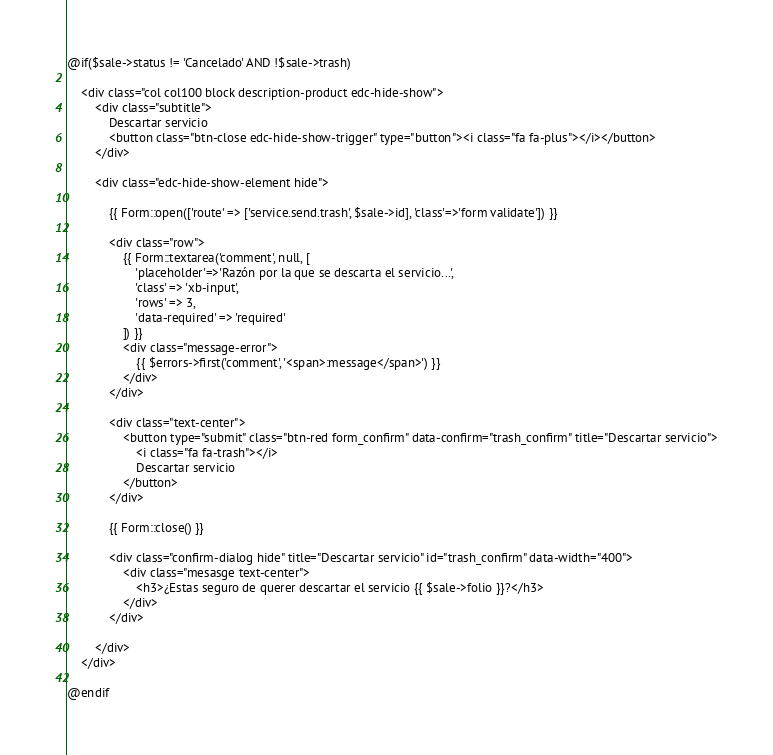Convert code to text. <code><loc_0><loc_0><loc_500><loc_500><_PHP_>@if($sale->status != 'Cancelado' AND !$sale->trash)

    <div class="col col100 block description-product edc-hide-show">
        <div class="subtitle">
            Descartar servicio
            <button class="btn-close edc-hide-show-trigger" type="button"><i class="fa fa-plus"></i></button>
        </div>

        <div class="edc-hide-show-element hide">

            {{ Form::open(['route' => ['service.send.trash', $sale->id], 'class'=>'form validate']) }}

            <div class="row">
                {{ Form::textarea('comment', null, [
                    'placeholder'=>'Razón por la que se descarta el servicio...',
                    'class' => 'xb-input',
                    'rows' => 3,
                    'data-required' => 'required'
                ]) }}
                <div class="message-error">
                    {{ $errors->first('comment', '<span>:message</span>') }}
                </div>
            </div>

            <div class="text-center">
                <button type="submit" class="btn-red form_confirm" data-confirm="trash_confirm" title="Descartar servicio">
                    <i class="fa fa-trash"></i>
                    Descartar servicio
                </button>
            </div>

            {{ Form::close() }}

            <div class="confirm-dialog hide" title="Descartar servicio" id="trash_confirm" data-width="400">
                <div class="mesasge text-center">
                    <h3>¿Estas seguro de querer descartar el servicio {{ $sale->folio }}?</h3>
                </div>
            </div>

        </div>
    </div>

@endif</code> 